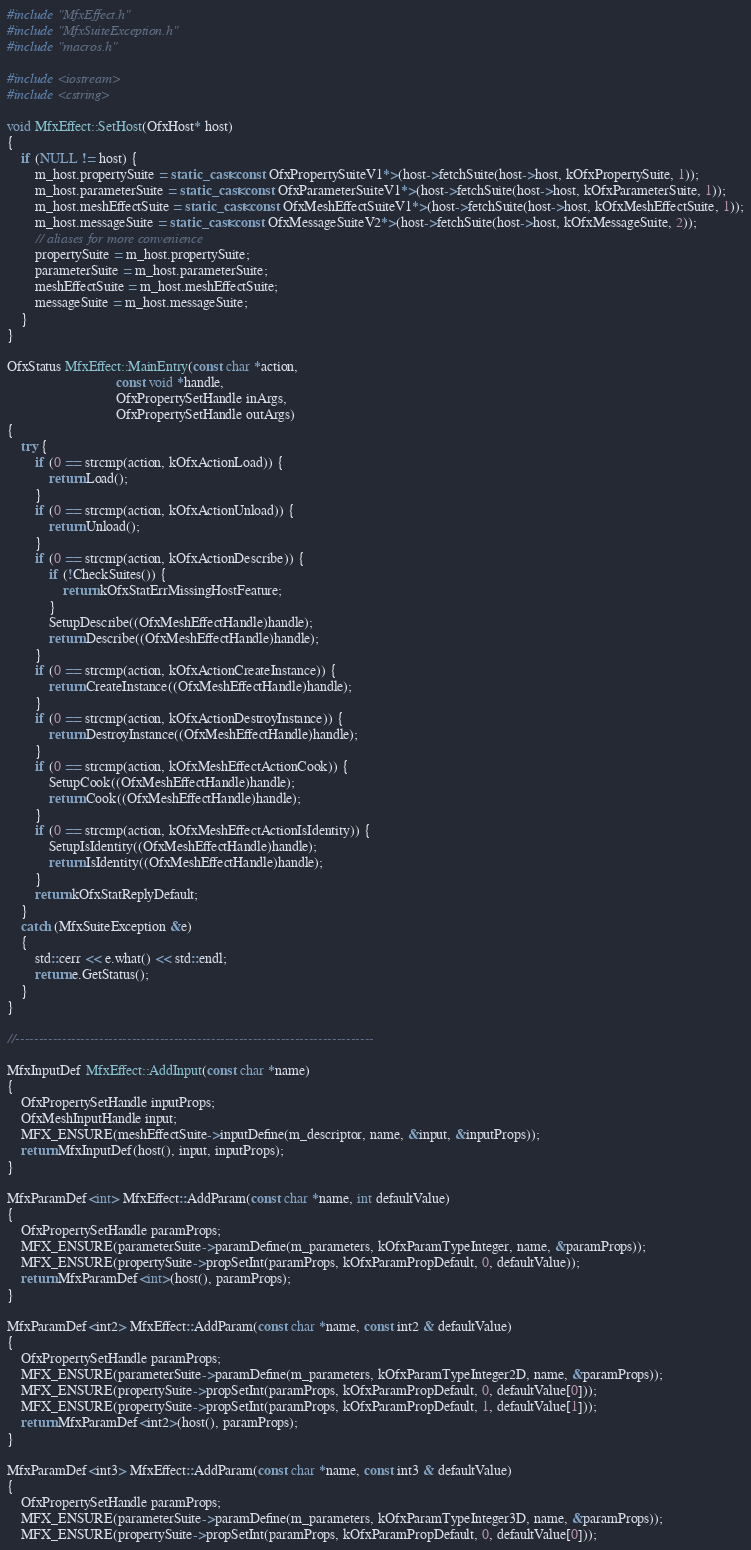Convert code to text. <code><loc_0><loc_0><loc_500><loc_500><_C++_>#include "MfxEffect.h"
#include "MfxSuiteException.h"
#include "macros.h"

#include <iostream>
#include <cstring>

void MfxEffect::SetHost(OfxHost* host)
{
    if (NULL != host) {
        m_host.propertySuite = static_cast<const OfxPropertySuiteV1*>(host->fetchSuite(host->host, kOfxPropertySuite, 1));
        m_host.parameterSuite = static_cast<const OfxParameterSuiteV1*>(host->fetchSuite(host->host, kOfxParameterSuite, 1));
        m_host.meshEffectSuite = static_cast<const OfxMeshEffectSuiteV1*>(host->fetchSuite(host->host, kOfxMeshEffectSuite, 1));
        m_host.messageSuite = static_cast<const OfxMessageSuiteV2*>(host->fetchSuite(host->host, kOfxMessageSuite, 2));
        // aliases for more convenience
        propertySuite = m_host.propertySuite;
        parameterSuite = m_host.parameterSuite;
        meshEffectSuite = m_host.meshEffectSuite;
        messageSuite = m_host.messageSuite;
    }
}

OfxStatus MfxEffect::MainEntry(const char *action,
                               const void *handle,
                               OfxPropertySetHandle inArgs,
                               OfxPropertySetHandle outArgs)
{
    try {
        if (0 == strcmp(action, kOfxActionLoad)) {
            return Load();
        }
        if (0 == strcmp(action, kOfxActionUnload)) {
            return Unload();
        }
        if (0 == strcmp(action, kOfxActionDescribe)) {
            if (!CheckSuites()) {
                return kOfxStatErrMissingHostFeature;
            }
            SetupDescribe((OfxMeshEffectHandle)handle);
            return Describe((OfxMeshEffectHandle)handle);
        }
        if (0 == strcmp(action, kOfxActionCreateInstance)) {
            return CreateInstance((OfxMeshEffectHandle)handle);
        }
        if (0 == strcmp(action, kOfxActionDestroyInstance)) {
            return DestroyInstance((OfxMeshEffectHandle)handle);
        }
        if (0 == strcmp(action, kOfxMeshEffectActionCook)) {
            SetupCook((OfxMeshEffectHandle)handle);
            return Cook((OfxMeshEffectHandle)handle);
        }
        if (0 == strcmp(action, kOfxMeshEffectActionIsIdentity)) {
            SetupIsIdentity((OfxMeshEffectHandle)handle);
            return IsIdentity((OfxMeshEffectHandle)handle);
        }
        return kOfxStatReplyDefault;
    }
    catch (MfxSuiteException &e)
    {
        std::cerr << e.what() << std::endl;
        return e.GetStatus();
    }
}

//-----------------------------------------------------------------------------

MfxInputDef MfxEffect::AddInput(const char *name)
{
    OfxPropertySetHandle inputProps;
    OfxMeshInputHandle input;
    MFX_ENSURE(meshEffectSuite->inputDefine(m_descriptor, name, &input, &inputProps));
    return MfxInputDef(host(), input, inputProps);
}

MfxParamDef<int> MfxEffect::AddParam(const char *name, int defaultValue)
{
    OfxPropertySetHandle paramProps;
    MFX_ENSURE(parameterSuite->paramDefine(m_parameters, kOfxParamTypeInteger, name, &paramProps));
    MFX_ENSURE(propertySuite->propSetInt(paramProps, kOfxParamPropDefault, 0, defaultValue));
    return MfxParamDef<int>(host(), paramProps);
}

MfxParamDef<int2> MfxEffect::AddParam(const char *name, const int2 & defaultValue)
{
    OfxPropertySetHandle paramProps;
    MFX_ENSURE(parameterSuite->paramDefine(m_parameters, kOfxParamTypeInteger2D, name, &paramProps));
    MFX_ENSURE(propertySuite->propSetInt(paramProps, kOfxParamPropDefault, 0, defaultValue[0]));
    MFX_ENSURE(propertySuite->propSetInt(paramProps, kOfxParamPropDefault, 1, defaultValue[1]));
    return MfxParamDef<int2>(host(), paramProps);
}

MfxParamDef<int3> MfxEffect::AddParam(const char *name, const int3 & defaultValue)
{
    OfxPropertySetHandle paramProps;
    MFX_ENSURE(parameterSuite->paramDefine(m_parameters, kOfxParamTypeInteger3D, name, &paramProps));
    MFX_ENSURE(propertySuite->propSetInt(paramProps, kOfxParamPropDefault, 0, defaultValue[0]));</code> 